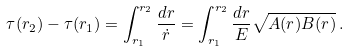<formula> <loc_0><loc_0><loc_500><loc_500>\tau ( r _ { 2 } ) - \tau ( r _ { 1 } ) = \int _ { r _ { 1 } } ^ { r _ { 2 } } \frac { d r } { \dot { r } } = \int _ { r _ { 1 } } ^ { r _ { 2 } } \frac { d r } { E } \sqrt { A ( r ) B ( r ) } \, .</formula> 